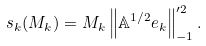Convert formula to latex. <formula><loc_0><loc_0><loc_500><loc_500>s _ { k } ( M _ { k } ) = M _ { k } \left \| \mathbb { A } ^ { 1 / 2 } e _ { k } \right \| _ { - 1 } ^ { \prime 2 } .</formula> 